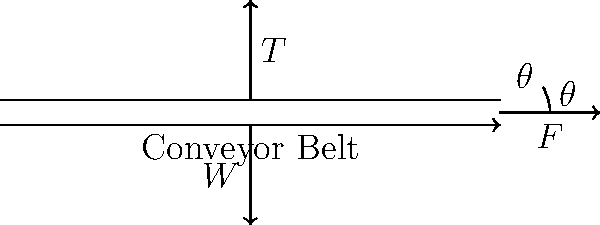A horizontal conveyor belt is carrying a load with a total weight $W = 1000$ N. The belt experiences a frictional force $F = 200$ N at an angle $\theta = 30°$ to the horizontal. Calculate the tension $T$ in the conveyor belt required to maintain equilibrium. To solve this problem, we'll use the principles of force equilibrium and trigonometry. Let's break it down step-by-step:

1) First, let's identify the forces acting on the system:
   - Weight ($W$) acting downwards: 1000 N
   - Friction force ($F$) at 30° to the horizontal: 200 N
   - Tension ($T$) in the belt, which we need to calculate

2) For equilibrium, the sum of forces in both horizontal and vertical directions must be zero.

3) Let's resolve the friction force into its horizontal and vertical components:
   - Horizontal component: $F_x = F \cos \theta = 200 \cos 30° = 200 \cdot \frac{\sqrt{3}}{2} \approx 173.2$ N
   - Vertical component: $F_y = F \sin \theta = 200 \sin 30° = 200 \cdot \frac{1}{2} = 100$ N

4) Now, let's write the equilibrium equations:
   - Horizontal: $T = F_x = 173.2$ N
   - Vertical: $N - W + F_y = 0$, where $N$ is the normal force (not needed for this problem)

5) The tension in the belt is equal to the horizontal component of the friction force.

Therefore, the tension $T$ in the conveyor belt is approximately 173.2 N.
Answer: $T \approx 173.2$ N 